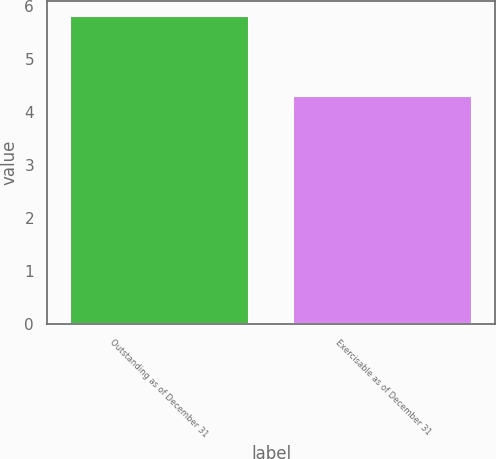Convert chart. <chart><loc_0><loc_0><loc_500><loc_500><bar_chart><fcel>Outstanding as of December 31<fcel>Exercisable as of December 31<nl><fcel>5.8<fcel>4.3<nl></chart> 